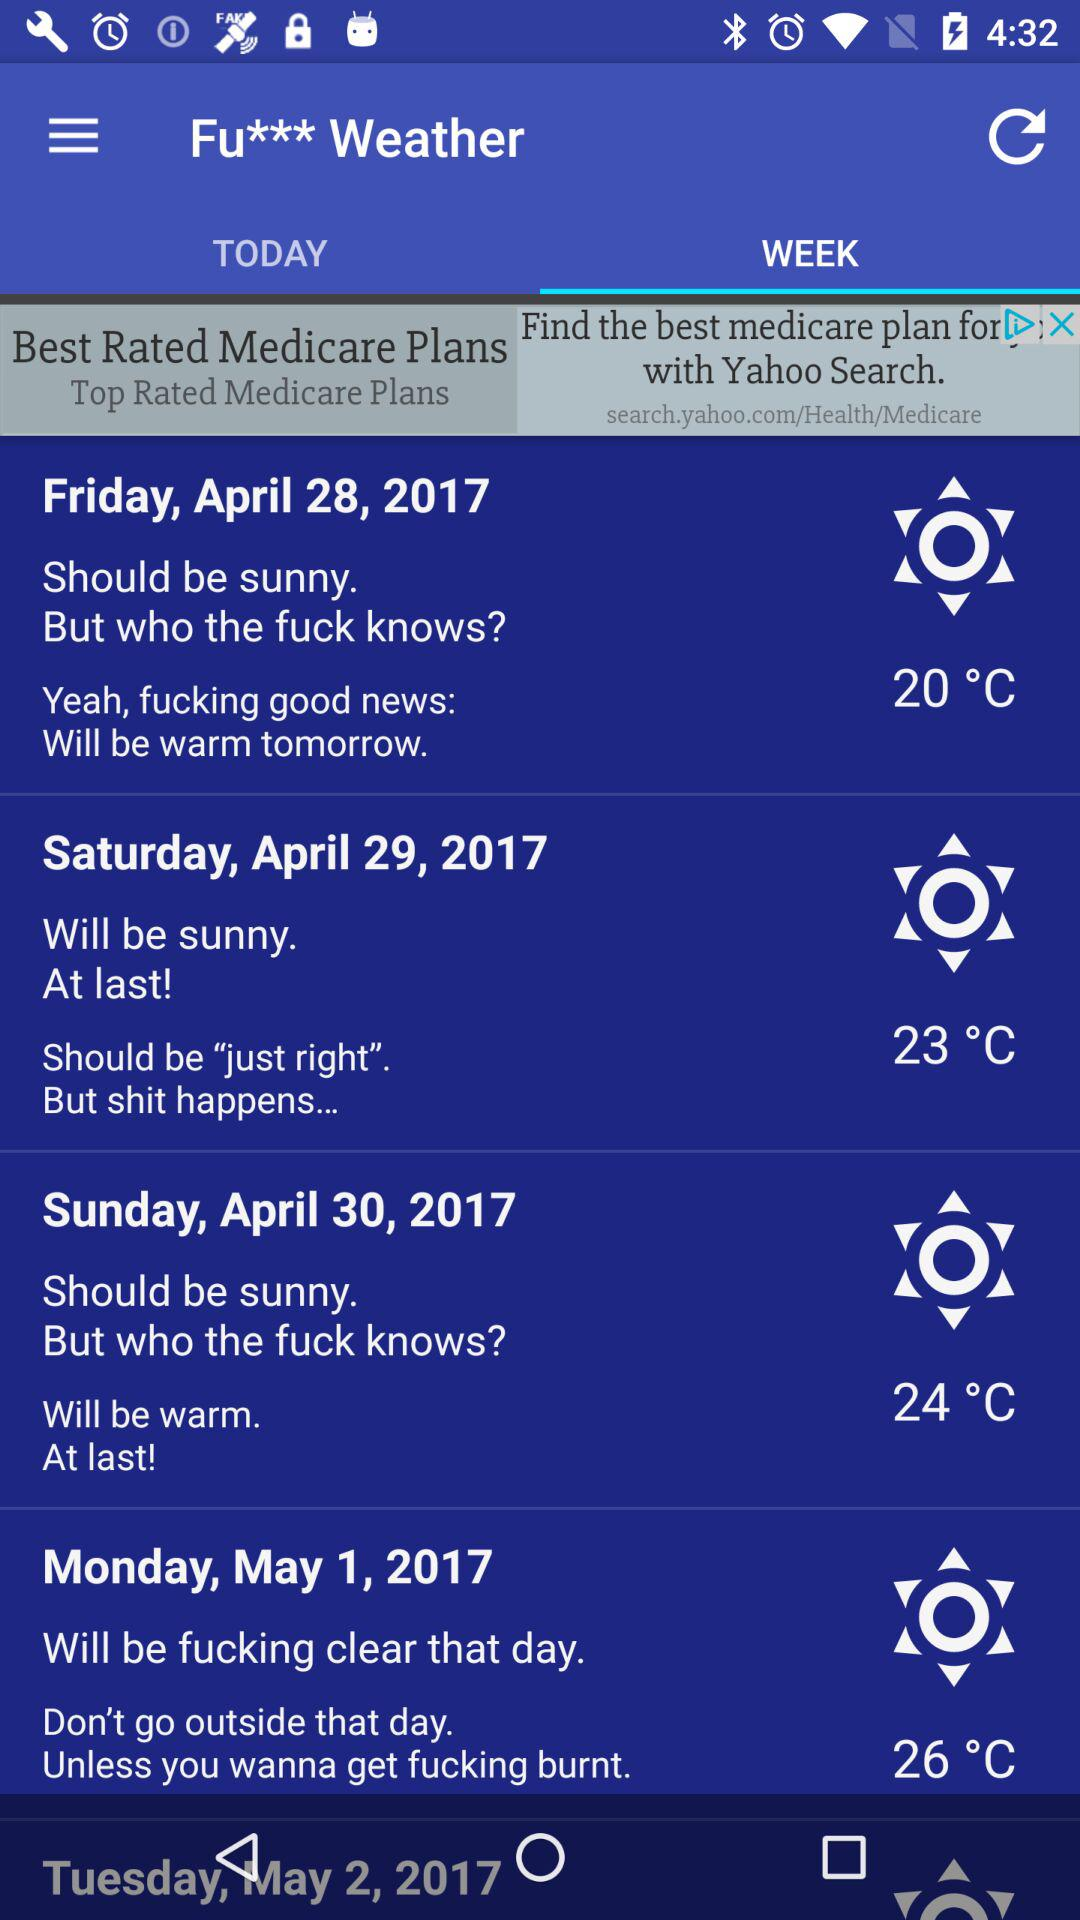How many days are the temperatures above 20 degrees celsius?
Answer the question using a single word or phrase. 3 